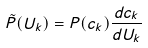<formula> <loc_0><loc_0><loc_500><loc_500>\tilde { P } ( U _ { k } ) = P ( c _ { k } ) \frac { d c _ { k } } { d U _ { k } }</formula> 